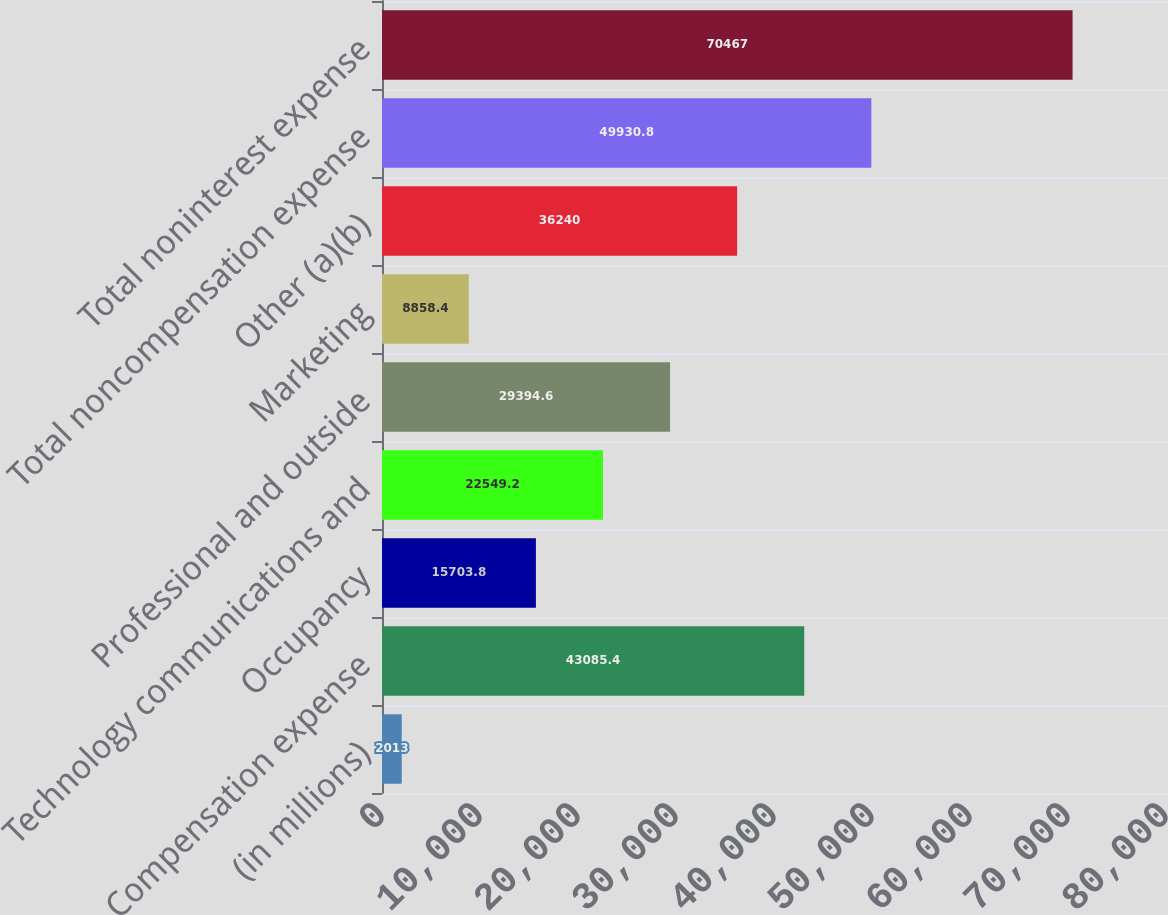<chart> <loc_0><loc_0><loc_500><loc_500><bar_chart><fcel>(in millions)<fcel>Compensation expense<fcel>Occupancy<fcel>Technology communications and<fcel>Professional and outside<fcel>Marketing<fcel>Other (a)(b)<fcel>Total noncompensation expense<fcel>Total noninterest expense<nl><fcel>2013<fcel>43085.4<fcel>15703.8<fcel>22549.2<fcel>29394.6<fcel>8858.4<fcel>36240<fcel>49930.8<fcel>70467<nl></chart> 